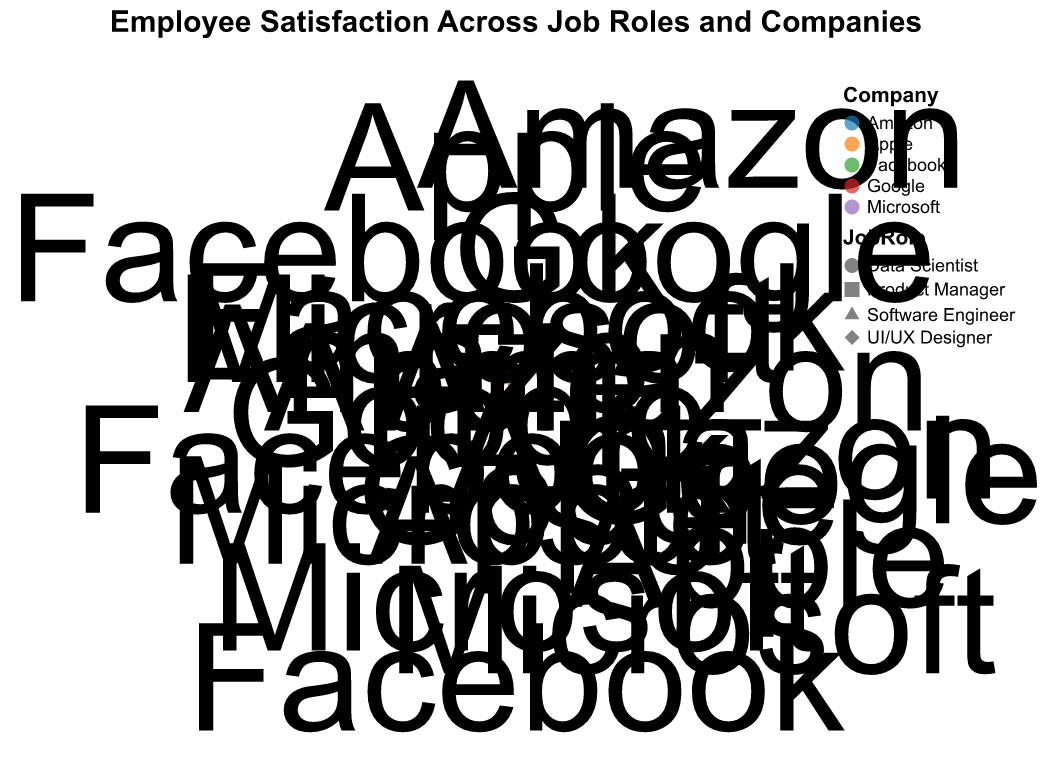What is the title of the plot? The title is located near the top center of the plot. It provides a quick understanding of what the chart is about.
Answer: Employee Satisfaction Across Job Roles and Companies How many unique job roles are represented in the plot? The distinct shapes in the plot represent different job roles. According to the encoding, they are circle, square, triangle, and diamond.
Answer: 4 Which company has the highest employee satisfaction among Data Scientists? First, identify the data points for Data Scientists. Then, find the highest EmployeeSatisfaction value among the identified points.
Answer: Facebook Which job role has the lowest satisfaction level, and what is the company associated with it? By comparing the lowest EmployeeSatisfaction values across different job roles and finding the associated company of that point.
Answer: Software Engineer, Apple Compare the average employee satisfaction between Software Engineers and Data Scientists. Which job role has a higher average? Calculate the average EmployeeSatisfaction for Software Engineers and Data Scientists by summing their values and dividing by the number of points in each group. Compare the two averages.
Answer: Data Scientist Among Product Managers, which company has the lowest employee satisfaction? Identify the points corresponding to Product Managers and find the one with the lowest EmployeeSatisfaction value.
Answer: Amazon What is the range of employee satisfaction levels for UI/UX Designers? Identify the highest and lowest EmployeeSatisfaction values among UI/UX Designers by examining their data points. Subtract the lowest value from the highest value.
Answer: 82 - 74 = 8 How many companies have employee satisfaction levels higher than 85 for any job role? Check each data point to see if the EmployeeSatisfaction is greater than 85. Note the unique companies that meet this criterion.
Answer: 4 What is the average employee satisfaction for employees at Google? Identify all data points representing Google. Sum their EmployeeSatisfaction values, then divide by the number of points.
Answer: (75 + 85 + 80 + 78) / 4 = 79.5 For which job role does Facebook exhibit the highest employee satisfaction? Find the data points associated with Facebook and compare the EmployeeSatisfaction values to determine the highest role.
Answer: Data Scientist 